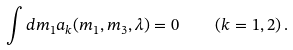Convert formula to latex. <formula><loc_0><loc_0><loc_500><loc_500>\int d m _ { 1 } a _ { k } ( m _ { 1 } , m _ { 3 } , \lambda ) = 0 \quad ( k = 1 , 2 ) \, .</formula> 